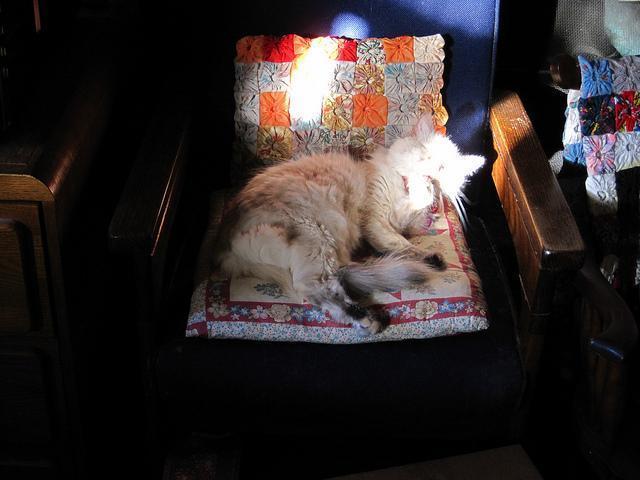How many chairs are visible?
Give a very brief answer. 1. 